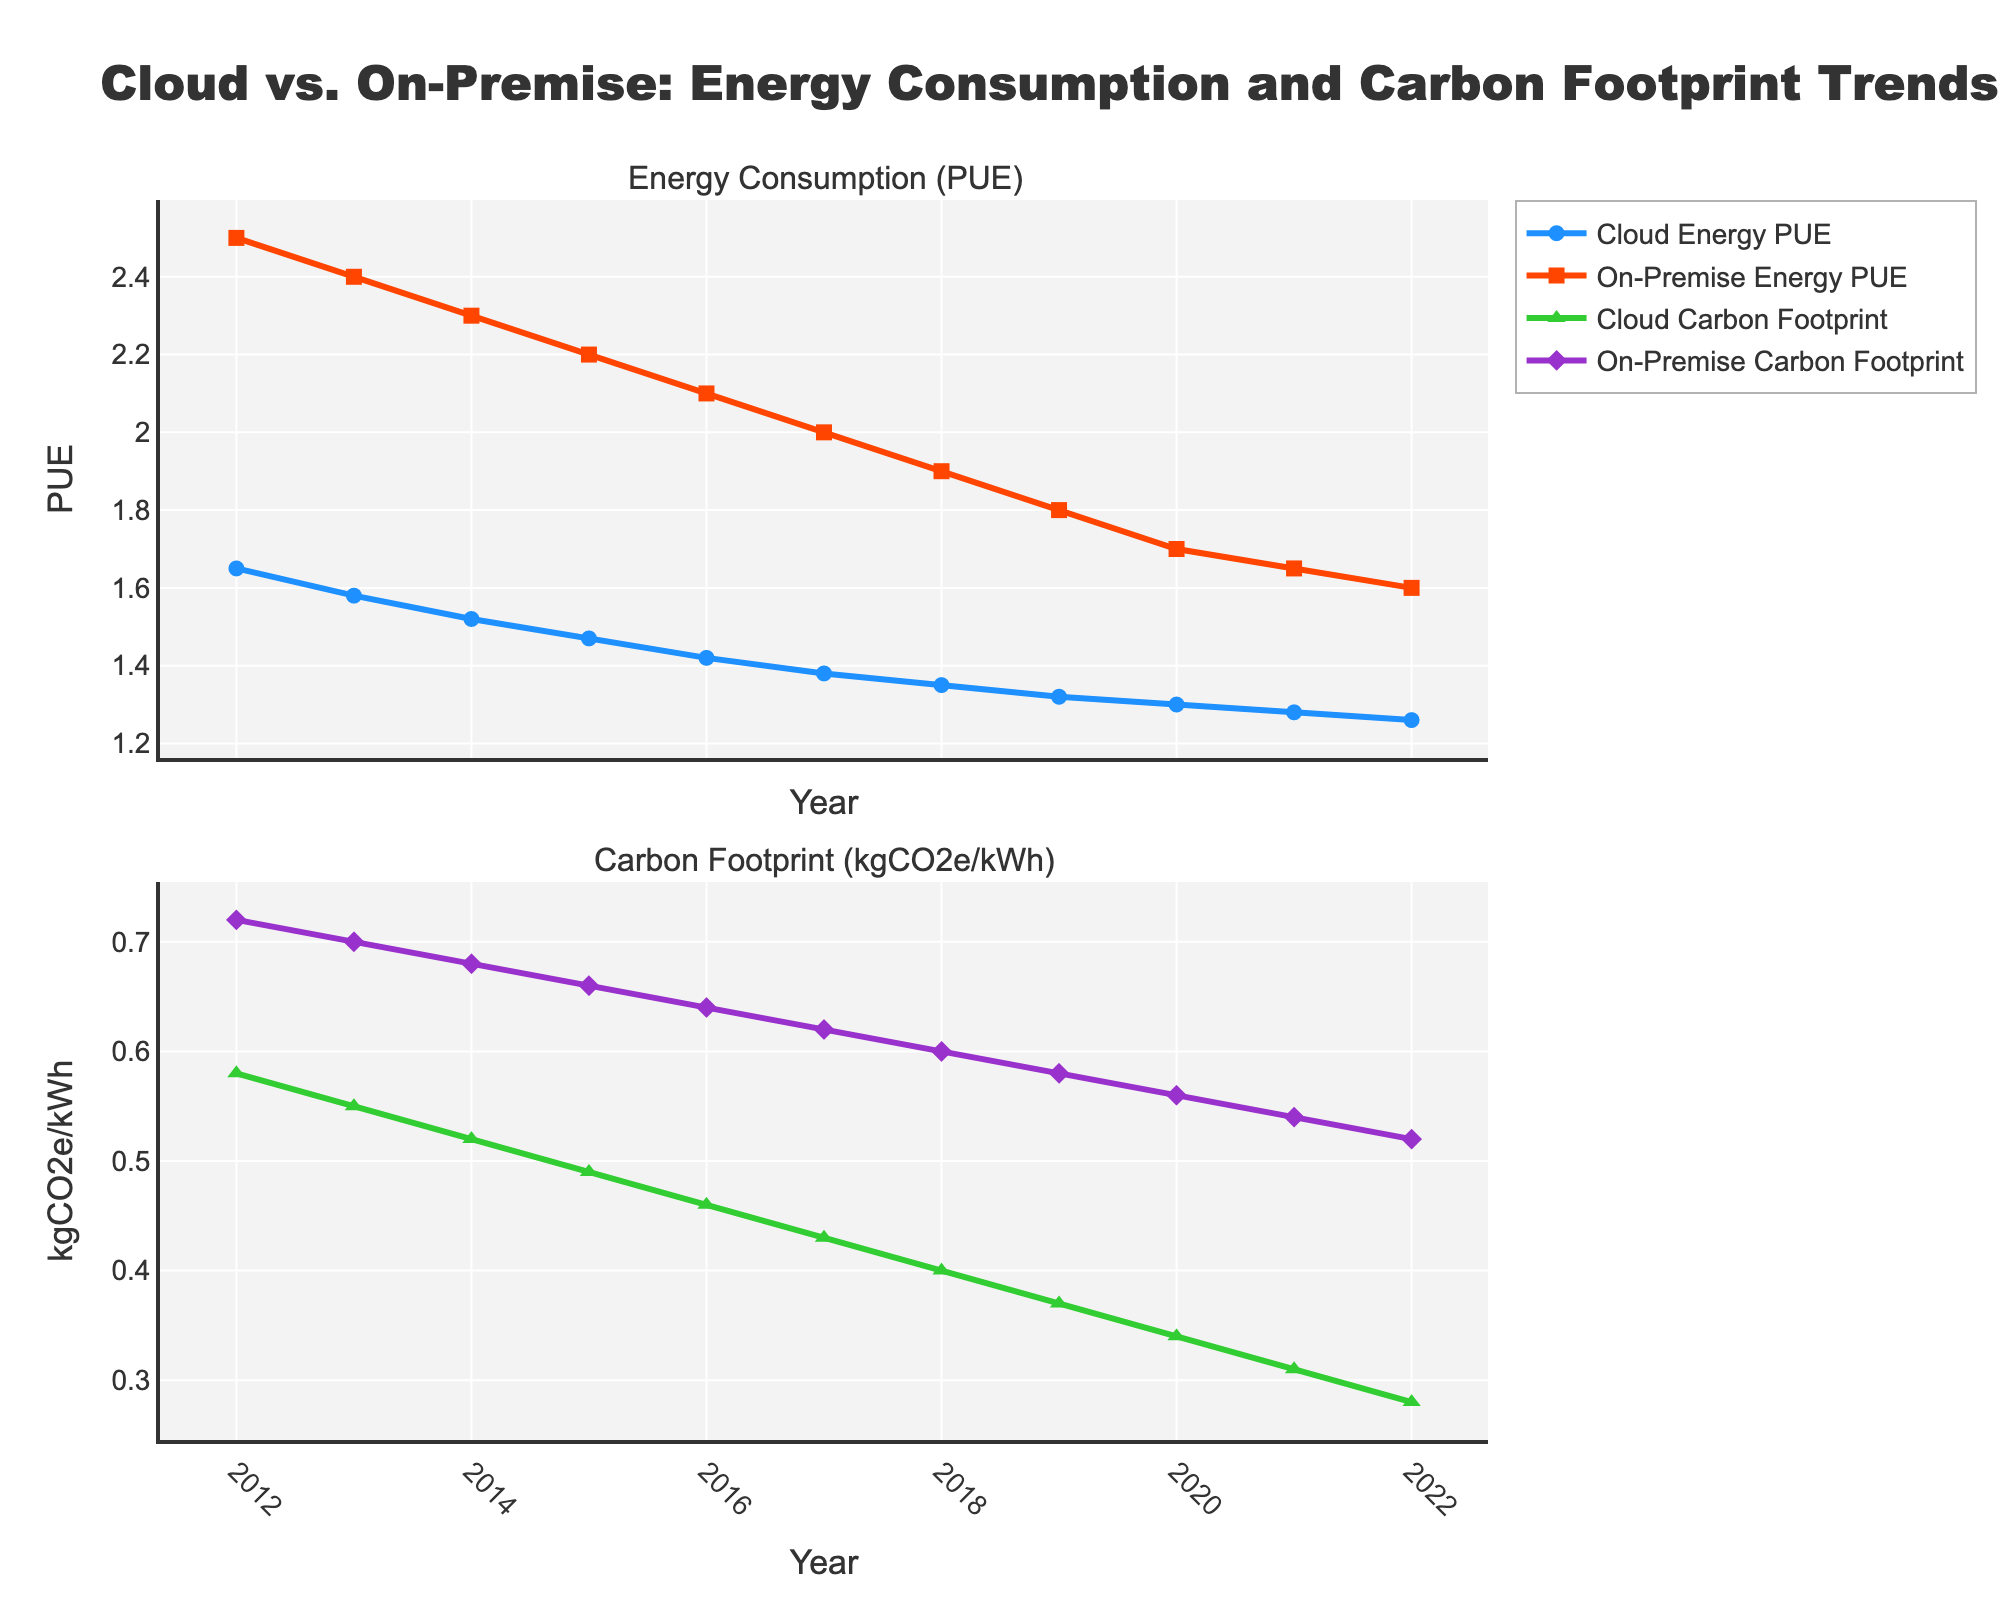What is the trend in Cloud Energy PUE over the decade? By observing the line representing Cloud Energy PUE from 2012 to 2022, it consistently decreases from 1.65 in 2012 to 1.26 in 2022. This indicates an overall downward trend in Cloud Energy PUE over the decade.
Answer: Downward trend Which year had the highest On-Premise Energy PUE and what was its value? The purple line representing On-Premise Energy PUE reaches its highest value in 2012. The value associated with this peak is 2.5.
Answer: 2012, 2.5 How does the Cloud Carbon Footprint compare to the On-Premise Carbon Footprint in 2022? In 2022, the green line representing Cloud Carbon Footprint is at 0.28 kgCO2e/kWh, while the purple line representing On-Premise Carbon Footprint is at 0.52 kgCO2e/kWh. The Cloud Carbon Footprint is significantly lower than the On-Premise Carbon Footprint.
Answer: Cloud is lower What is the difference in Cloud Energy PUE between the years 2013 and 2017? In 2013, the Cloud Energy PUE is 1.58, and in 2017, it is 1.38. The difference is calculated as 1.58 - 1.38 = 0.2.
Answer: 0.2 What is the average Cloud Carbon Footprint over the entire decade? First, sum all yearly Cloud Carbon Footprint values from 2012 to 2022: (0.58 + 0.55 + 0.52 + 0.49 + 0.46 + 0.43 + 0.40 + 0.37 + 0.34 + 0.31 + 0.28) = 4.73. There are 11 values in total. The average is therefore 4.73 / 11 = 0.43 kgCO2e/kWh.
Answer: 0.43 kgCO2e/kWh By how much did the On-Premise Carbon Footprint decrease from 2012 to 2022? In 2012, the On-Premise Carbon Footprint was 0.72 kgCO2e/kWh. In 2022, it was 0.52 kgCO2e/kWh. The decrease is calculated as 0.72 - 0.52 = 0.20 kgCO2e/kWh.
Answer: 0.20 kgCO2e/kWh Is there any year where On-Premise Energy PUE was equal to Cloud Energy PUE? By inspecting the lines for both On-Premise Energy PUE and Cloud Energy PUE, there is no year where both values are equal. The On-Premise Energy PUE remains higher than Cloud Energy PUE throughout the decade.
Answer: No When comparing the energy efficiency trend, which data center type shows a steeper decrease in PUE? By examining the slopes of the lines, the On-Premise Energy PUE line depicting a steep decrease from 2.5 in 2012 to 1.6 in 2022, is steeper compared to the Cloud Energy PUE line which decreases from 1.65 to 1.26 in the same period.
Answer: On-Premise What is the PUE difference between the cloud and on-premise data centers in 2015? In 2015, the Cloud Energy PUE is 1.47, and the On-Premise Energy PUE is 2.2. The difference is calculated as 2.2 - 1.47 = 0.73.
Answer: 0.73 